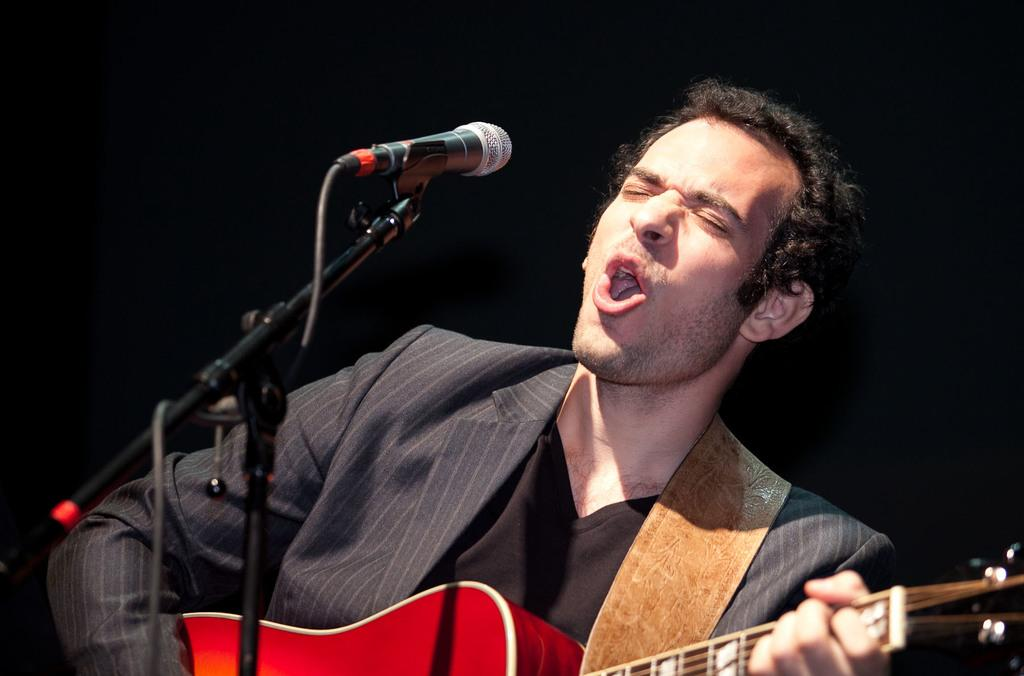What is the man in the image doing? The man is playing a guitar and singing. What object is the man using to amplify his voice? The man is using a microphone. What type of home improvement operation is the man performing in the image? There is no home improvement operation present in the image; the man is playing a guitar and singing. What type of basket is the man using to hold his guitar in the image? There is no basket present in the image; the man is holding the guitar with his hands. 